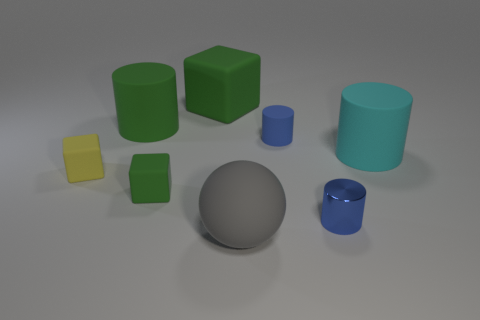What size is the cyan object that is made of the same material as the gray object?
Make the answer very short. Large. Are there fewer cyan matte spheres than small matte blocks?
Your answer should be very brief. Yes. There is a block that is the same size as the gray sphere; what material is it?
Offer a very short reply. Rubber. Is the number of tiny yellow matte cubes greater than the number of tiny metal cubes?
Keep it short and to the point. Yes. How many other things are the same color as the tiny matte cylinder?
Offer a very short reply. 1. How many tiny rubber objects are on the right side of the gray ball and to the left of the gray ball?
Provide a short and direct response. 0. Is there any other thing that is the same size as the metal thing?
Your answer should be very brief. Yes. Is the number of tiny blue metal things that are left of the metal thing greater than the number of blue objects in front of the gray matte object?
Ensure brevity in your answer.  No. There is a blue thing that is behind the large cyan matte cylinder; what is its material?
Offer a very short reply. Rubber. There is a tiny yellow matte object; does it have the same shape as the rubber object to the right of the shiny cylinder?
Provide a short and direct response. No. 